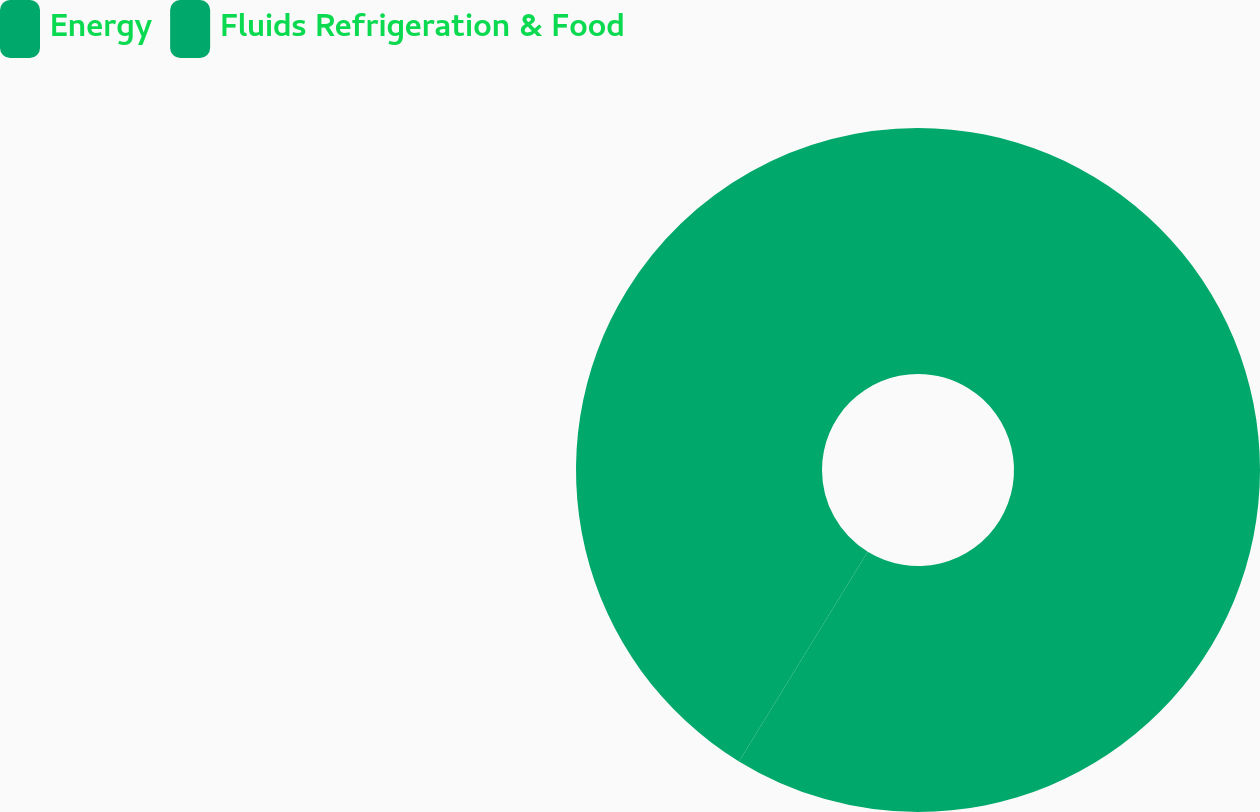<chart> <loc_0><loc_0><loc_500><loc_500><pie_chart><fcel>Energy<fcel>Fluids Refrigeration & Food<nl><fcel>58.77%<fcel>41.23%<nl></chart> 